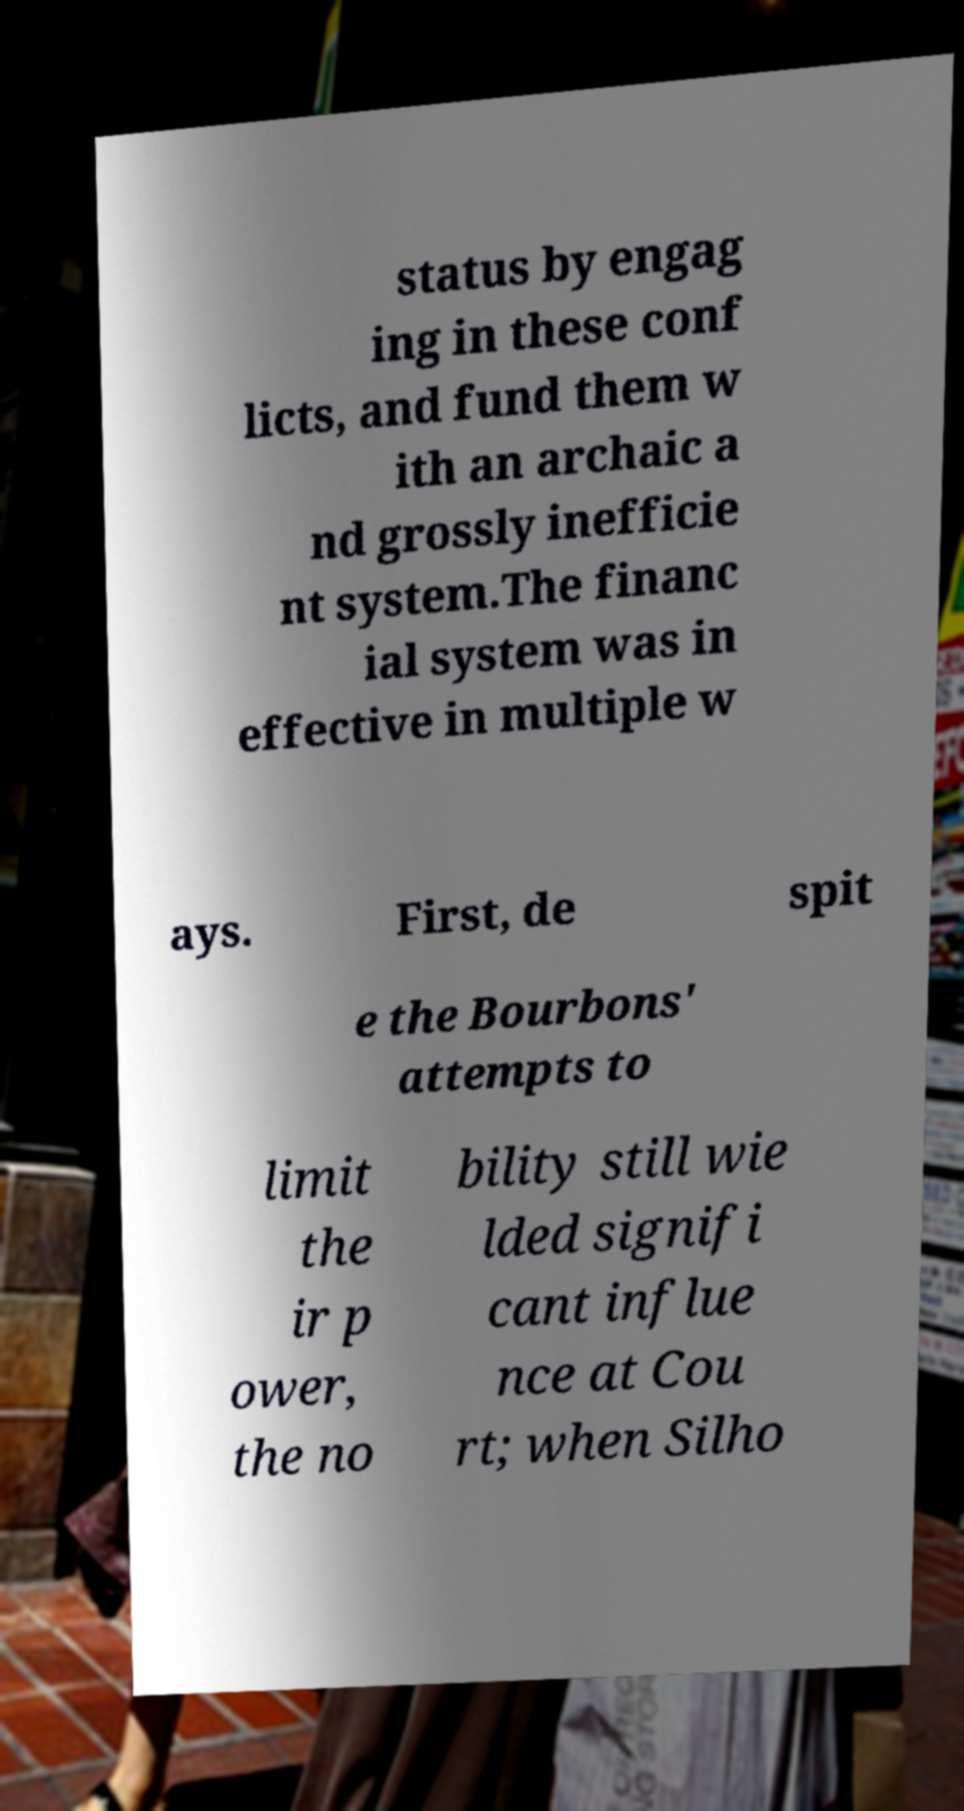Please identify and transcribe the text found in this image. status by engag ing in these conf licts, and fund them w ith an archaic a nd grossly inefficie nt system.The financ ial system was in effective in multiple w ays. First, de spit e the Bourbons' attempts to limit the ir p ower, the no bility still wie lded signifi cant influe nce at Cou rt; when Silho 